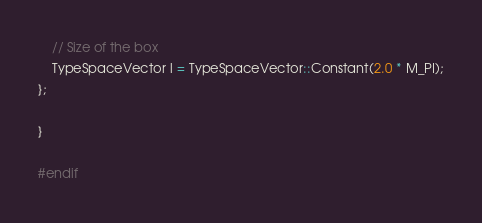Convert code to text. <code><loc_0><loc_0><loc_500><loc_500><_C_>    // Size of the box
    TypeSpaceVector l = TypeSpaceVector::Constant(2.0 * M_PI);
};

}

#endif
</code> 